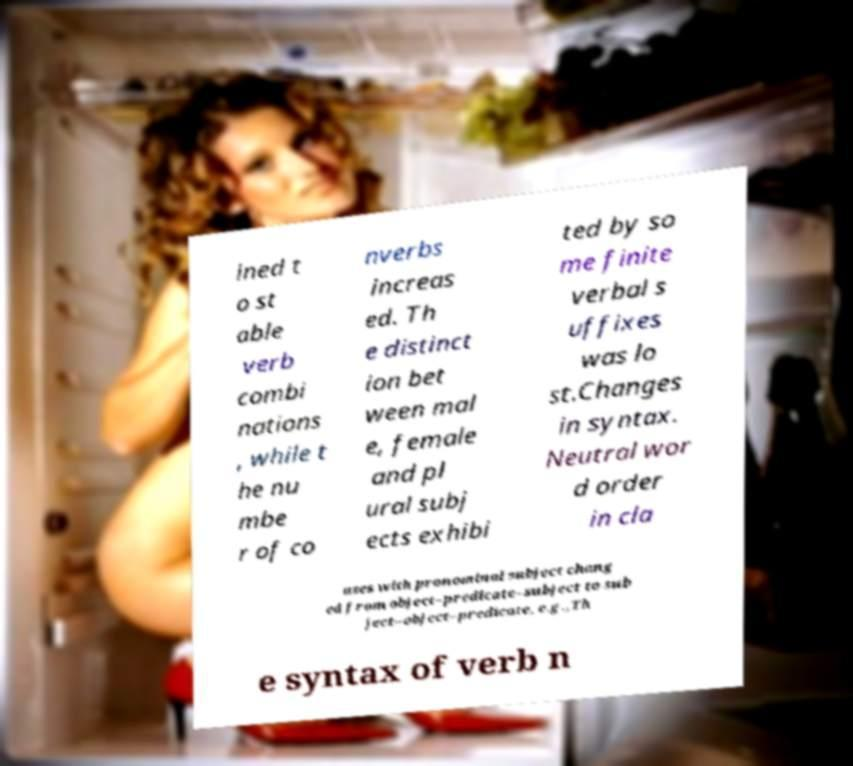Could you assist in decoding the text presented in this image and type it out clearly? ined t o st able verb combi nations , while t he nu mbe r of co nverbs increas ed. Th e distinct ion bet ween mal e, female and pl ural subj ects exhibi ted by so me finite verbal s uffixes was lo st.Changes in syntax. Neutral wor d order in cla uses with pronominal subject chang ed from object–predicate–subject to sub ject–object–predicate, e.g.,Th e syntax of verb n 